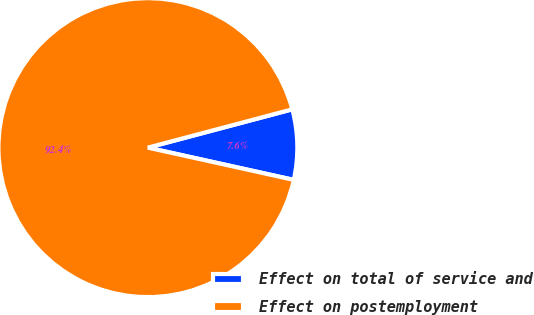Convert chart to OTSL. <chart><loc_0><loc_0><loc_500><loc_500><pie_chart><fcel>Effect on total of service and<fcel>Effect on postemployment<nl><fcel>7.59%<fcel>92.41%<nl></chart> 